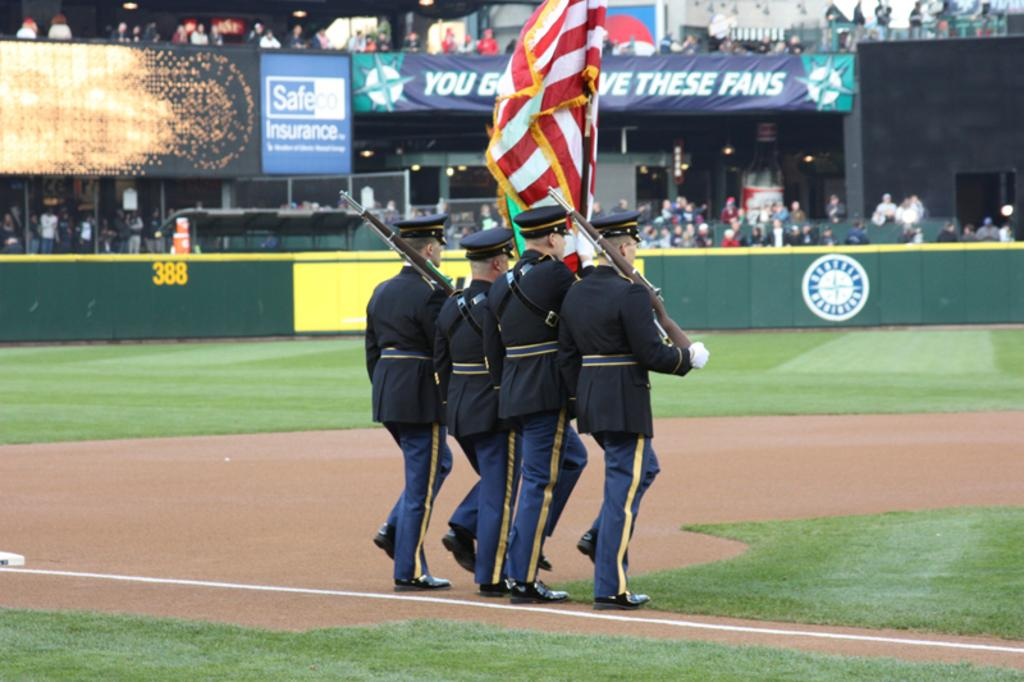<image>
Write a terse but informative summary of the picture. Four military members march on a baseball field in front of a Safeco Insurance advertisement. 